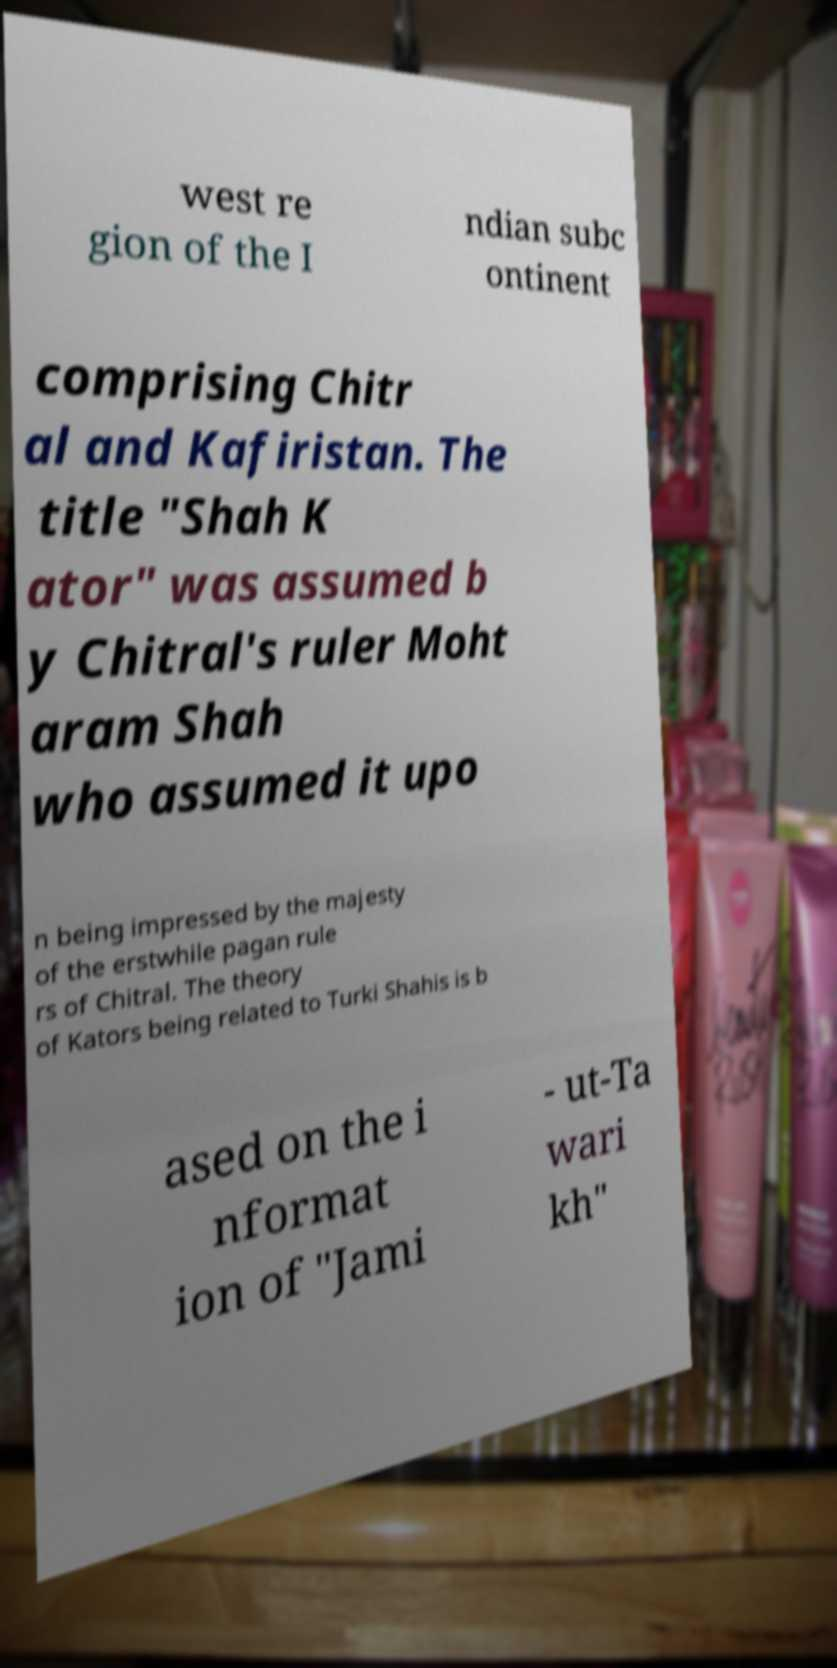Please identify and transcribe the text found in this image. west re gion of the I ndian subc ontinent comprising Chitr al and Kafiristan. The title "Shah K ator" was assumed b y Chitral's ruler Moht aram Shah who assumed it upo n being impressed by the majesty of the erstwhile pagan rule rs of Chitral. The theory of Kators being related to Turki Shahis is b ased on the i nformat ion of "Jami - ut-Ta wari kh" 